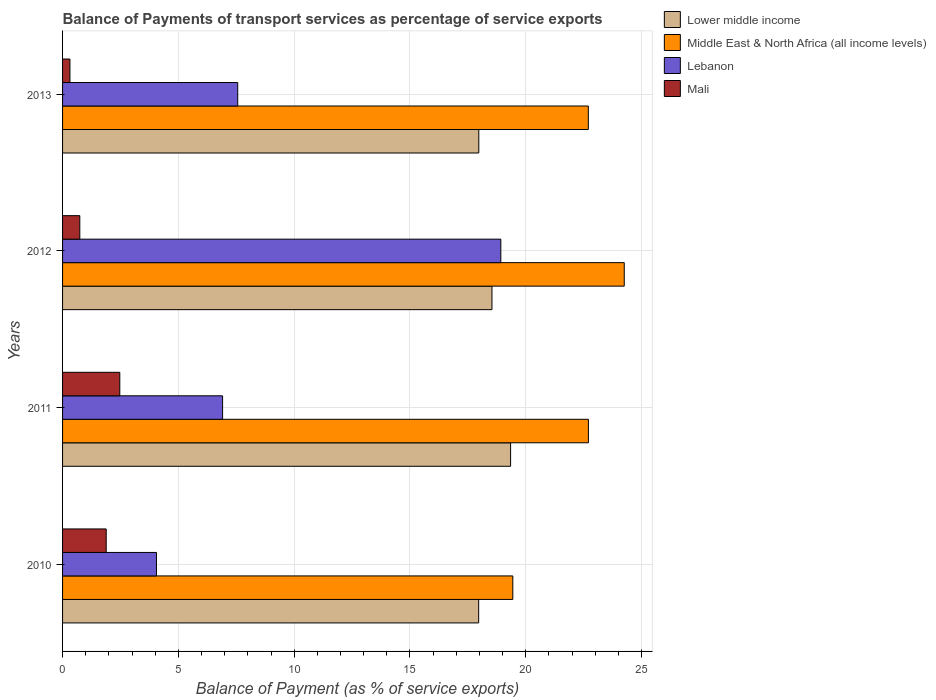How many groups of bars are there?
Provide a short and direct response. 4. Are the number of bars per tick equal to the number of legend labels?
Your response must be concise. Yes. How many bars are there on the 2nd tick from the top?
Provide a short and direct response. 4. How many bars are there on the 4th tick from the bottom?
Make the answer very short. 4. What is the label of the 3rd group of bars from the top?
Your response must be concise. 2011. In how many cases, is the number of bars for a given year not equal to the number of legend labels?
Offer a terse response. 0. What is the balance of payments of transport services in Mali in 2010?
Ensure brevity in your answer.  1.88. Across all years, what is the maximum balance of payments of transport services in Lebanon?
Offer a very short reply. 18.92. Across all years, what is the minimum balance of payments of transport services in Middle East & North Africa (all income levels)?
Provide a succinct answer. 19.44. In which year was the balance of payments of transport services in Mali minimum?
Offer a terse response. 2013. What is the total balance of payments of transport services in Lebanon in the graph?
Ensure brevity in your answer.  37.45. What is the difference between the balance of payments of transport services in Mali in 2011 and that in 2013?
Ensure brevity in your answer.  2.15. What is the difference between the balance of payments of transport services in Middle East & North Africa (all income levels) in 2010 and the balance of payments of transport services in Lebanon in 2013?
Your response must be concise. 11.88. What is the average balance of payments of transport services in Mali per year?
Your answer should be very brief. 1.35. In the year 2011, what is the difference between the balance of payments of transport services in Mali and balance of payments of transport services in Middle East & North Africa (all income levels)?
Give a very brief answer. -20.23. What is the ratio of the balance of payments of transport services in Lebanon in 2010 to that in 2012?
Ensure brevity in your answer.  0.21. Is the balance of payments of transport services in Middle East & North Africa (all income levels) in 2010 less than that in 2012?
Your response must be concise. Yes. What is the difference between the highest and the second highest balance of payments of transport services in Lower middle income?
Give a very brief answer. 0.8. What is the difference between the highest and the lowest balance of payments of transport services in Lower middle income?
Your response must be concise. 1.38. What does the 4th bar from the top in 2013 represents?
Provide a short and direct response. Lower middle income. What does the 4th bar from the bottom in 2013 represents?
Offer a terse response. Mali. Is it the case that in every year, the sum of the balance of payments of transport services in Lebanon and balance of payments of transport services in Lower middle income is greater than the balance of payments of transport services in Mali?
Keep it short and to the point. Yes. What is the difference between two consecutive major ticks on the X-axis?
Your answer should be very brief. 5. How are the legend labels stacked?
Provide a succinct answer. Vertical. What is the title of the graph?
Ensure brevity in your answer.  Balance of Payments of transport services as percentage of service exports. Does "Uzbekistan" appear as one of the legend labels in the graph?
Ensure brevity in your answer.  No. What is the label or title of the X-axis?
Provide a succinct answer. Balance of Payment (as % of service exports). What is the label or title of the Y-axis?
Your response must be concise. Years. What is the Balance of Payment (as % of service exports) of Lower middle income in 2010?
Ensure brevity in your answer.  17.97. What is the Balance of Payment (as % of service exports) in Middle East & North Africa (all income levels) in 2010?
Ensure brevity in your answer.  19.44. What is the Balance of Payment (as % of service exports) of Lebanon in 2010?
Provide a short and direct response. 4.05. What is the Balance of Payment (as % of service exports) in Mali in 2010?
Keep it short and to the point. 1.88. What is the Balance of Payment (as % of service exports) in Lower middle income in 2011?
Provide a succinct answer. 19.34. What is the Balance of Payment (as % of service exports) of Middle East & North Africa (all income levels) in 2011?
Your answer should be compact. 22.7. What is the Balance of Payment (as % of service exports) of Lebanon in 2011?
Offer a very short reply. 6.91. What is the Balance of Payment (as % of service exports) of Mali in 2011?
Keep it short and to the point. 2.47. What is the Balance of Payment (as % of service exports) in Lower middle income in 2012?
Ensure brevity in your answer.  18.54. What is the Balance of Payment (as % of service exports) in Middle East & North Africa (all income levels) in 2012?
Your answer should be very brief. 24.25. What is the Balance of Payment (as % of service exports) of Lebanon in 2012?
Provide a short and direct response. 18.92. What is the Balance of Payment (as % of service exports) of Mali in 2012?
Your answer should be compact. 0.74. What is the Balance of Payment (as % of service exports) in Lower middle income in 2013?
Provide a succinct answer. 17.97. What is the Balance of Payment (as % of service exports) of Middle East & North Africa (all income levels) in 2013?
Make the answer very short. 22.7. What is the Balance of Payment (as % of service exports) in Lebanon in 2013?
Offer a very short reply. 7.56. What is the Balance of Payment (as % of service exports) of Mali in 2013?
Give a very brief answer. 0.32. Across all years, what is the maximum Balance of Payment (as % of service exports) in Lower middle income?
Your answer should be compact. 19.34. Across all years, what is the maximum Balance of Payment (as % of service exports) in Middle East & North Africa (all income levels)?
Ensure brevity in your answer.  24.25. Across all years, what is the maximum Balance of Payment (as % of service exports) of Lebanon?
Offer a very short reply. 18.92. Across all years, what is the maximum Balance of Payment (as % of service exports) in Mali?
Your response must be concise. 2.47. Across all years, what is the minimum Balance of Payment (as % of service exports) in Lower middle income?
Offer a very short reply. 17.97. Across all years, what is the minimum Balance of Payment (as % of service exports) of Middle East & North Africa (all income levels)?
Your answer should be very brief. 19.44. Across all years, what is the minimum Balance of Payment (as % of service exports) of Lebanon?
Offer a terse response. 4.05. Across all years, what is the minimum Balance of Payment (as % of service exports) in Mali?
Your answer should be compact. 0.32. What is the total Balance of Payment (as % of service exports) of Lower middle income in the graph?
Your answer should be compact. 73.82. What is the total Balance of Payment (as % of service exports) of Middle East & North Africa (all income levels) in the graph?
Keep it short and to the point. 89.09. What is the total Balance of Payment (as % of service exports) of Lebanon in the graph?
Offer a very short reply. 37.45. What is the total Balance of Payment (as % of service exports) in Mali in the graph?
Keep it short and to the point. 5.42. What is the difference between the Balance of Payment (as % of service exports) in Lower middle income in 2010 and that in 2011?
Offer a very short reply. -1.38. What is the difference between the Balance of Payment (as % of service exports) in Middle East & North Africa (all income levels) in 2010 and that in 2011?
Ensure brevity in your answer.  -3.26. What is the difference between the Balance of Payment (as % of service exports) of Lebanon in 2010 and that in 2011?
Provide a succinct answer. -2.85. What is the difference between the Balance of Payment (as % of service exports) of Mali in 2010 and that in 2011?
Your response must be concise. -0.59. What is the difference between the Balance of Payment (as % of service exports) in Lower middle income in 2010 and that in 2012?
Give a very brief answer. -0.57. What is the difference between the Balance of Payment (as % of service exports) in Middle East & North Africa (all income levels) in 2010 and that in 2012?
Keep it short and to the point. -4.81. What is the difference between the Balance of Payment (as % of service exports) in Lebanon in 2010 and that in 2012?
Offer a very short reply. -14.87. What is the difference between the Balance of Payment (as % of service exports) in Mali in 2010 and that in 2012?
Provide a short and direct response. 1.14. What is the difference between the Balance of Payment (as % of service exports) of Lower middle income in 2010 and that in 2013?
Offer a very short reply. -0.01. What is the difference between the Balance of Payment (as % of service exports) in Middle East & North Africa (all income levels) in 2010 and that in 2013?
Provide a succinct answer. -3.26. What is the difference between the Balance of Payment (as % of service exports) of Lebanon in 2010 and that in 2013?
Your response must be concise. -3.51. What is the difference between the Balance of Payment (as % of service exports) of Mali in 2010 and that in 2013?
Keep it short and to the point. 1.57. What is the difference between the Balance of Payment (as % of service exports) in Lower middle income in 2011 and that in 2012?
Your answer should be very brief. 0.8. What is the difference between the Balance of Payment (as % of service exports) of Middle East & North Africa (all income levels) in 2011 and that in 2012?
Provide a succinct answer. -1.55. What is the difference between the Balance of Payment (as % of service exports) of Lebanon in 2011 and that in 2012?
Give a very brief answer. -12.01. What is the difference between the Balance of Payment (as % of service exports) in Mali in 2011 and that in 2012?
Your answer should be very brief. 1.73. What is the difference between the Balance of Payment (as % of service exports) of Lower middle income in 2011 and that in 2013?
Provide a succinct answer. 1.37. What is the difference between the Balance of Payment (as % of service exports) in Middle East & North Africa (all income levels) in 2011 and that in 2013?
Keep it short and to the point. 0. What is the difference between the Balance of Payment (as % of service exports) in Lebanon in 2011 and that in 2013?
Your response must be concise. -0.65. What is the difference between the Balance of Payment (as % of service exports) of Mali in 2011 and that in 2013?
Your answer should be compact. 2.15. What is the difference between the Balance of Payment (as % of service exports) of Lower middle income in 2012 and that in 2013?
Ensure brevity in your answer.  0.57. What is the difference between the Balance of Payment (as % of service exports) in Middle East & North Africa (all income levels) in 2012 and that in 2013?
Ensure brevity in your answer.  1.55. What is the difference between the Balance of Payment (as % of service exports) in Lebanon in 2012 and that in 2013?
Your answer should be compact. 11.36. What is the difference between the Balance of Payment (as % of service exports) in Mali in 2012 and that in 2013?
Keep it short and to the point. 0.43. What is the difference between the Balance of Payment (as % of service exports) of Lower middle income in 2010 and the Balance of Payment (as % of service exports) of Middle East & North Africa (all income levels) in 2011?
Make the answer very short. -4.74. What is the difference between the Balance of Payment (as % of service exports) of Lower middle income in 2010 and the Balance of Payment (as % of service exports) of Lebanon in 2011?
Your answer should be very brief. 11.06. What is the difference between the Balance of Payment (as % of service exports) of Lower middle income in 2010 and the Balance of Payment (as % of service exports) of Mali in 2011?
Provide a succinct answer. 15.49. What is the difference between the Balance of Payment (as % of service exports) in Middle East & North Africa (all income levels) in 2010 and the Balance of Payment (as % of service exports) in Lebanon in 2011?
Make the answer very short. 12.53. What is the difference between the Balance of Payment (as % of service exports) in Middle East & North Africa (all income levels) in 2010 and the Balance of Payment (as % of service exports) in Mali in 2011?
Your answer should be very brief. 16.97. What is the difference between the Balance of Payment (as % of service exports) of Lebanon in 2010 and the Balance of Payment (as % of service exports) of Mali in 2011?
Provide a short and direct response. 1.58. What is the difference between the Balance of Payment (as % of service exports) in Lower middle income in 2010 and the Balance of Payment (as % of service exports) in Middle East & North Africa (all income levels) in 2012?
Provide a short and direct response. -6.29. What is the difference between the Balance of Payment (as % of service exports) of Lower middle income in 2010 and the Balance of Payment (as % of service exports) of Lebanon in 2012?
Provide a short and direct response. -0.96. What is the difference between the Balance of Payment (as % of service exports) of Lower middle income in 2010 and the Balance of Payment (as % of service exports) of Mali in 2012?
Offer a terse response. 17.22. What is the difference between the Balance of Payment (as % of service exports) of Middle East & North Africa (all income levels) in 2010 and the Balance of Payment (as % of service exports) of Lebanon in 2012?
Give a very brief answer. 0.52. What is the difference between the Balance of Payment (as % of service exports) in Middle East & North Africa (all income levels) in 2010 and the Balance of Payment (as % of service exports) in Mali in 2012?
Provide a succinct answer. 18.7. What is the difference between the Balance of Payment (as % of service exports) of Lebanon in 2010 and the Balance of Payment (as % of service exports) of Mali in 2012?
Your answer should be compact. 3.31. What is the difference between the Balance of Payment (as % of service exports) in Lower middle income in 2010 and the Balance of Payment (as % of service exports) in Middle East & North Africa (all income levels) in 2013?
Offer a very short reply. -4.73. What is the difference between the Balance of Payment (as % of service exports) of Lower middle income in 2010 and the Balance of Payment (as % of service exports) of Lebanon in 2013?
Make the answer very short. 10.4. What is the difference between the Balance of Payment (as % of service exports) of Lower middle income in 2010 and the Balance of Payment (as % of service exports) of Mali in 2013?
Offer a terse response. 17.65. What is the difference between the Balance of Payment (as % of service exports) of Middle East & North Africa (all income levels) in 2010 and the Balance of Payment (as % of service exports) of Lebanon in 2013?
Your response must be concise. 11.88. What is the difference between the Balance of Payment (as % of service exports) in Middle East & North Africa (all income levels) in 2010 and the Balance of Payment (as % of service exports) in Mali in 2013?
Give a very brief answer. 19.12. What is the difference between the Balance of Payment (as % of service exports) in Lebanon in 2010 and the Balance of Payment (as % of service exports) in Mali in 2013?
Offer a terse response. 3.74. What is the difference between the Balance of Payment (as % of service exports) in Lower middle income in 2011 and the Balance of Payment (as % of service exports) in Middle East & North Africa (all income levels) in 2012?
Offer a terse response. -4.91. What is the difference between the Balance of Payment (as % of service exports) in Lower middle income in 2011 and the Balance of Payment (as % of service exports) in Lebanon in 2012?
Your answer should be very brief. 0.42. What is the difference between the Balance of Payment (as % of service exports) of Lower middle income in 2011 and the Balance of Payment (as % of service exports) of Mali in 2012?
Your response must be concise. 18.6. What is the difference between the Balance of Payment (as % of service exports) in Middle East & North Africa (all income levels) in 2011 and the Balance of Payment (as % of service exports) in Lebanon in 2012?
Offer a very short reply. 3.78. What is the difference between the Balance of Payment (as % of service exports) in Middle East & North Africa (all income levels) in 2011 and the Balance of Payment (as % of service exports) in Mali in 2012?
Offer a very short reply. 21.96. What is the difference between the Balance of Payment (as % of service exports) of Lebanon in 2011 and the Balance of Payment (as % of service exports) of Mali in 2012?
Make the answer very short. 6.16. What is the difference between the Balance of Payment (as % of service exports) of Lower middle income in 2011 and the Balance of Payment (as % of service exports) of Middle East & North Africa (all income levels) in 2013?
Keep it short and to the point. -3.36. What is the difference between the Balance of Payment (as % of service exports) in Lower middle income in 2011 and the Balance of Payment (as % of service exports) in Lebanon in 2013?
Ensure brevity in your answer.  11.78. What is the difference between the Balance of Payment (as % of service exports) of Lower middle income in 2011 and the Balance of Payment (as % of service exports) of Mali in 2013?
Ensure brevity in your answer.  19.03. What is the difference between the Balance of Payment (as % of service exports) of Middle East & North Africa (all income levels) in 2011 and the Balance of Payment (as % of service exports) of Lebanon in 2013?
Provide a short and direct response. 15.14. What is the difference between the Balance of Payment (as % of service exports) in Middle East & North Africa (all income levels) in 2011 and the Balance of Payment (as % of service exports) in Mali in 2013?
Keep it short and to the point. 22.39. What is the difference between the Balance of Payment (as % of service exports) of Lebanon in 2011 and the Balance of Payment (as % of service exports) of Mali in 2013?
Make the answer very short. 6.59. What is the difference between the Balance of Payment (as % of service exports) in Lower middle income in 2012 and the Balance of Payment (as % of service exports) in Middle East & North Africa (all income levels) in 2013?
Your answer should be compact. -4.16. What is the difference between the Balance of Payment (as % of service exports) of Lower middle income in 2012 and the Balance of Payment (as % of service exports) of Lebanon in 2013?
Keep it short and to the point. 10.98. What is the difference between the Balance of Payment (as % of service exports) of Lower middle income in 2012 and the Balance of Payment (as % of service exports) of Mali in 2013?
Your answer should be very brief. 18.22. What is the difference between the Balance of Payment (as % of service exports) in Middle East & North Africa (all income levels) in 2012 and the Balance of Payment (as % of service exports) in Lebanon in 2013?
Offer a very short reply. 16.69. What is the difference between the Balance of Payment (as % of service exports) in Middle East & North Africa (all income levels) in 2012 and the Balance of Payment (as % of service exports) in Mali in 2013?
Offer a very short reply. 23.93. What is the difference between the Balance of Payment (as % of service exports) in Lebanon in 2012 and the Balance of Payment (as % of service exports) in Mali in 2013?
Provide a succinct answer. 18.6. What is the average Balance of Payment (as % of service exports) of Lower middle income per year?
Offer a terse response. 18.45. What is the average Balance of Payment (as % of service exports) of Middle East & North Africa (all income levels) per year?
Ensure brevity in your answer.  22.27. What is the average Balance of Payment (as % of service exports) in Lebanon per year?
Keep it short and to the point. 9.36. What is the average Balance of Payment (as % of service exports) of Mali per year?
Keep it short and to the point. 1.35. In the year 2010, what is the difference between the Balance of Payment (as % of service exports) in Lower middle income and Balance of Payment (as % of service exports) in Middle East & North Africa (all income levels)?
Provide a short and direct response. -1.47. In the year 2010, what is the difference between the Balance of Payment (as % of service exports) in Lower middle income and Balance of Payment (as % of service exports) in Lebanon?
Provide a short and direct response. 13.91. In the year 2010, what is the difference between the Balance of Payment (as % of service exports) in Lower middle income and Balance of Payment (as % of service exports) in Mali?
Make the answer very short. 16.08. In the year 2010, what is the difference between the Balance of Payment (as % of service exports) in Middle East & North Africa (all income levels) and Balance of Payment (as % of service exports) in Lebanon?
Make the answer very short. 15.39. In the year 2010, what is the difference between the Balance of Payment (as % of service exports) of Middle East & North Africa (all income levels) and Balance of Payment (as % of service exports) of Mali?
Give a very brief answer. 17.56. In the year 2010, what is the difference between the Balance of Payment (as % of service exports) in Lebanon and Balance of Payment (as % of service exports) in Mali?
Offer a very short reply. 2.17. In the year 2011, what is the difference between the Balance of Payment (as % of service exports) in Lower middle income and Balance of Payment (as % of service exports) in Middle East & North Africa (all income levels)?
Make the answer very short. -3.36. In the year 2011, what is the difference between the Balance of Payment (as % of service exports) in Lower middle income and Balance of Payment (as % of service exports) in Lebanon?
Provide a succinct answer. 12.43. In the year 2011, what is the difference between the Balance of Payment (as % of service exports) in Lower middle income and Balance of Payment (as % of service exports) in Mali?
Provide a succinct answer. 16.87. In the year 2011, what is the difference between the Balance of Payment (as % of service exports) in Middle East & North Africa (all income levels) and Balance of Payment (as % of service exports) in Lebanon?
Your response must be concise. 15.79. In the year 2011, what is the difference between the Balance of Payment (as % of service exports) in Middle East & North Africa (all income levels) and Balance of Payment (as % of service exports) in Mali?
Your answer should be very brief. 20.23. In the year 2011, what is the difference between the Balance of Payment (as % of service exports) of Lebanon and Balance of Payment (as % of service exports) of Mali?
Your response must be concise. 4.44. In the year 2012, what is the difference between the Balance of Payment (as % of service exports) in Lower middle income and Balance of Payment (as % of service exports) in Middle East & North Africa (all income levels)?
Provide a succinct answer. -5.71. In the year 2012, what is the difference between the Balance of Payment (as % of service exports) in Lower middle income and Balance of Payment (as % of service exports) in Lebanon?
Provide a succinct answer. -0.38. In the year 2012, what is the difference between the Balance of Payment (as % of service exports) of Lower middle income and Balance of Payment (as % of service exports) of Mali?
Make the answer very short. 17.79. In the year 2012, what is the difference between the Balance of Payment (as % of service exports) of Middle East & North Africa (all income levels) and Balance of Payment (as % of service exports) of Lebanon?
Your answer should be compact. 5.33. In the year 2012, what is the difference between the Balance of Payment (as % of service exports) in Middle East & North Africa (all income levels) and Balance of Payment (as % of service exports) in Mali?
Offer a terse response. 23.51. In the year 2012, what is the difference between the Balance of Payment (as % of service exports) of Lebanon and Balance of Payment (as % of service exports) of Mali?
Your response must be concise. 18.18. In the year 2013, what is the difference between the Balance of Payment (as % of service exports) in Lower middle income and Balance of Payment (as % of service exports) in Middle East & North Africa (all income levels)?
Offer a very short reply. -4.73. In the year 2013, what is the difference between the Balance of Payment (as % of service exports) of Lower middle income and Balance of Payment (as % of service exports) of Lebanon?
Give a very brief answer. 10.41. In the year 2013, what is the difference between the Balance of Payment (as % of service exports) in Lower middle income and Balance of Payment (as % of service exports) in Mali?
Provide a succinct answer. 17.65. In the year 2013, what is the difference between the Balance of Payment (as % of service exports) of Middle East & North Africa (all income levels) and Balance of Payment (as % of service exports) of Lebanon?
Provide a short and direct response. 15.14. In the year 2013, what is the difference between the Balance of Payment (as % of service exports) in Middle East & North Africa (all income levels) and Balance of Payment (as % of service exports) in Mali?
Offer a very short reply. 22.38. In the year 2013, what is the difference between the Balance of Payment (as % of service exports) in Lebanon and Balance of Payment (as % of service exports) in Mali?
Provide a succinct answer. 7.24. What is the ratio of the Balance of Payment (as % of service exports) of Lower middle income in 2010 to that in 2011?
Keep it short and to the point. 0.93. What is the ratio of the Balance of Payment (as % of service exports) in Middle East & North Africa (all income levels) in 2010 to that in 2011?
Provide a succinct answer. 0.86. What is the ratio of the Balance of Payment (as % of service exports) of Lebanon in 2010 to that in 2011?
Your answer should be very brief. 0.59. What is the ratio of the Balance of Payment (as % of service exports) in Mali in 2010 to that in 2011?
Keep it short and to the point. 0.76. What is the ratio of the Balance of Payment (as % of service exports) in Lower middle income in 2010 to that in 2012?
Provide a short and direct response. 0.97. What is the ratio of the Balance of Payment (as % of service exports) in Middle East & North Africa (all income levels) in 2010 to that in 2012?
Make the answer very short. 0.8. What is the ratio of the Balance of Payment (as % of service exports) in Lebanon in 2010 to that in 2012?
Make the answer very short. 0.21. What is the ratio of the Balance of Payment (as % of service exports) in Mali in 2010 to that in 2012?
Provide a succinct answer. 2.53. What is the ratio of the Balance of Payment (as % of service exports) in Middle East & North Africa (all income levels) in 2010 to that in 2013?
Offer a very short reply. 0.86. What is the ratio of the Balance of Payment (as % of service exports) in Lebanon in 2010 to that in 2013?
Offer a very short reply. 0.54. What is the ratio of the Balance of Payment (as % of service exports) in Mali in 2010 to that in 2013?
Make the answer very short. 5.92. What is the ratio of the Balance of Payment (as % of service exports) of Lower middle income in 2011 to that in 2012?
Give a very brief answer. 1.04. What is the ratio of the Balance of Payment (as % of service exports) in Middle East & North Africa (all income levels) in 2011 to that in 2012?
Your response must be concise. 0.94. What is the ratio of the Balance of Payment (as % of service exports) in Lebanon in 2011 to that in 2012?
Ensure brevity in your answer.  0.37. What is the ratio of the Balance of Payment (as % of service exports) of Mali in 2011 to that in 2012?
Offer a very short reply. 3.32. What is the ratio of the Balance of Payment (as % of service exports) in Lower middle income in 2011 to that in 2013?
Keep it short and to the point. 1.08. What is the ratio of the Balance of Payment (as % of service exports) of Middle East & North Africa (all income levels) in 2011 to that in 2013?
Offer a terse response. 1. What is the ratio of the Balance of Payment (as % of service exports) in Lebanon in 2011 to that in 2013?
Give a very brief answer. 0.91. What is the ratio of the Balance of Payment (as % of service exports) in Mali in 2011 to that in 2013?
Your response must be concise. 7.77. What is the ratio of the Balance of Payment (as % of service exports) of Lower middle income in 2012 to that in 2013?
Provide a short and direct response. 1.03. What is the ratio of the Balance of Payment (as % of service exports) in Middle East & North Africa (all income levels) in 2012 to that in 2013?
Keep it short and to the point. 1.07. What is the ratio of the Balance of Payment (as % of service exports) in Lebanon in 2012 to that in 2013?
Provide a short and direct response. 2.5. What is the ratio of the Balance of Payment (as % of service exports) in Mali in 2012 to that in 2013?
Provide a short and direct response. 2.34. What is the difference between the highest and the second highest Balance of Payment (as % of service exports) of Lower middle income?
Your answer should be compact. 0.8. What is the difference between the highest and the second highest Balance of Payment (as % of service exports) in Middle East & North Africa (all income levels)?
Provide a succinct answer. 1.55. What is the difference between the highest and the second highest Balance of Payment (as % of service exports) of Lebanon?
Keep it short and to the point. 11.36. What is the difference between the highest and the second highest Balance of Payment (as % of service exports) of Mali?
Your answer should be very brief. 0.59. What is the difference between the highest and the lowest Balance of Payment (as % of service exports) in Lower middle income?
Make the answer very short. 1.38. What is the difference between the highest and the lowest Balance of Payment (as % of service exports) of Middle East & North Africa (all income levels)?
Your response must be concise. 4.81. What is the difference between the highest and the lowest Balance of Payment (as % of service exports) of Lebanon?
Your answer should be compact. 14.87. What is the difference between the highest and the lowest Balance of Payment (as % of service exports) of Mali?
Your answer should be very brief. 2.15. 